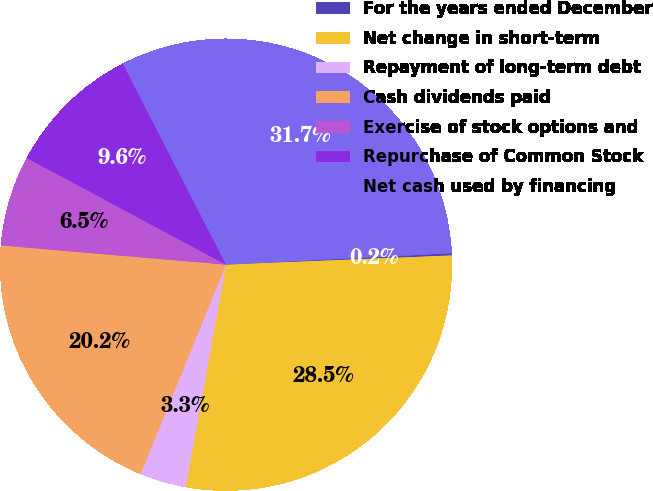Convert chart. <chart><loc_0><loc_0><loc_500><loc_500><pie_chart><fcel>For the years ended December<fcel>Net change in short-term<fcel>Repayment of long-term debt<fcel>Cash dividends paid<fcel>Exercise of stock options and<fcel>Repurchase of Common Stock<fcel>Net cash used by financing<nl><fcel>0.15%<fcel>28.51%<fcel>3.31%<fcel>20.19%<fcel>6.47%<fcel>9.63%<fcel>31.74%<nl></chart> 